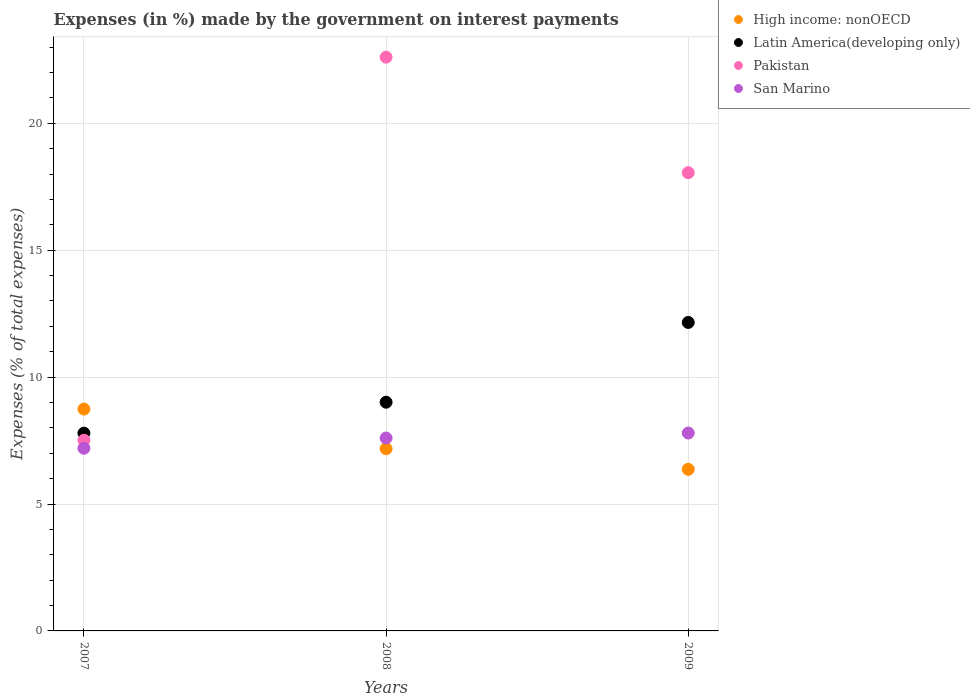How many different coloured dotlines are there?
Your answer should be compact. 4. Is the number of dotlines equal to the number of legend labels?
Ensure brevity in your answer.  Yes. What is the percentage of expenses made by the government on interest payments in Latin America(developing only) in 2009?
Provide a succinct answer. 12.15. Across all years, what is the maximum percentage of expenses made by the government on interest payments in High income: nonOECD?
Provide a short and direct response. 8.74. Across all years, what is the minimum percentage of expenses made by the government on interest payments in Pakistan?
Offer a very short reply. 7.51. What is the total percentage of expenses made by the government on interest payments in Latin America(developing only) in the graph?
Your response must be concise. 28.96. What is the difference between the percentage of expenses made by the government on interest payments in High income: nonOECD in 2007 and that in 2008?
Keep it short and to the point. 1.56. What is the difference between the percentage of expenses made by the government on interest payments in High income: nonOECD in 2008 and the percentage of expenses made by the government on interest payments in San Marino in 2009?
Give a very brief answer. -0.62. What is the average percentage of expenses made by the government on interest payments in High income: nonOECD per year?
Give a very brief answer. 7.43. In the year 2007, what is the difference between the percentage of expenses made by the government on interest payments in High income: nonOECD and percentage of expenses made by the government on interest payments in Latin America(developing only)?
Your answer should be very brief. 0.95. In how many years, is the percentage of expenses made by the government on interest payments in Latin America(developing only) greater than 9 %?
Keep it short and to the point. 2. What is the ratio of the percentage of expenses made by the government on interest payments in San Marino in 2007 to that in 2009?
Your answer should be very brief. 0.92. Is the difference between the percentage of expenses made by the government on interest payments in High income: nonOECD in 2008 and 2009 greater than the difference between the percentage of expenses made by the government on interest payments in Latin America(developing only) in 2008 and 2009?
Your response must be concise. Yes. What is the difference between the highest and the second highest percentage of expenses made by the government on interest payments in San Marino?
Offer a terse response. 0.2. What is the difference between the highest and the lowest percentage of expenses made by the government on interest payments in High income: nonOECD?
Keep it short and to the point. 2.37. In how many years, is the percentage of expenses made by the government on interest payments in High income: nonOECD greater than the average percentage of expenses made by the government on interest payments in High income: nonOECD taken over all years?
Your answer should be very brief. 1. Is the sum of the percentage of expenses made by the government on interest payments in High income: nonOECD in 2007 and 2009 greater than the maximum percentage of expenses made by the government on interest payments in San Marino across all years?
Make the answer very short. Yes. Does the percentage of expenses made by the government on interest payments in Latin America(developing only) monotonically increase over the years?
Ensure brevity in your answer.  Yes. Is the percentage of expenses made by the government on interest payments in San Marino strictly greater than the percentage of expenses made by the government on interest payments in Pakistan over the years?
Provide a succinct answer. No. How many dotlines are there?
Keep it short and to the point. 4. How many legend labels are there?
Keep it short and to the point. 4. What is the title of the graph?
Ensure brevity in your answer.  Expenses (in %) made by the government on interest payments. Does "Aruba" appear as one of the legend labels in the graph?
Your response must be concise. No. What is the label or title of the Y-axis?
Give a very brief answer. Expenses (% of total expenses). What is the Expenses (% of total expenses) in High income: nonOECD in 2007?
Ensure brevity in your answer.  8.74. What is the Expenses (% of total expenses) of Latin America(developing only) in 2007?
Your response must be concise. 7.79. What is the Expenses (% of total expenses) in Pakistan in 2007?
Your answer should be compact. 7.51. What is the Expenses (% of total expenses) of San Marino in 2007?
Offer a very short reply. 7.2. What is the Expenses (% of total expenses) in High income: nonOECD in 2008?
Provide a succinct answer. 7.18. What is the Expenses (% of total expenses) in Latin America(developing only) in 2008?
Give a very brief answer. 9.01. What is the Expenses (% of total expenses) in Pakistan in 2008?
Your response must be concise. 22.6. What is the Expenses (% of total expenses) of San Marino in 2008?
Give a very brief answer. 7.6. What is the Expenses (% of total expenses) in High income: nonOECD in 2009?
Your answer should be very brief. 6.37. What is the Expenses (% of total expenses) of Latin America(developing only) in 2009?
Provide a short and direct response. 12.15. What is the Expenses (% of total expenses) in Pakistan in 2009?
Offer a terse response. 18.05. What is the Expenses (% of total expenses) of San Marino in 2009?
Your answer should be very brief. 7.8. Across all years, what is the maximum Expenses (% of total expenses) in High income: nonOECD?
Provide a succinct answer. 8.74. Across all years, what is the maximum Expenses (% of total expenses) in Latin America(developing only)?
Your answer should be compact. 12.15. Across all years, what is the maximum Expenses (% of total expenses) of Pakistan?
Your answer should be very brief. 22.6. Across all years, what is the maximum Expenses (% of total expenses) in San Marino?
Ensure brevity in your answer.  7.8. Across all years, what is the minimum Expenses (% of total expenses) of High income: nonOECD?
Your answer should be very brief. 6.37. Across all years, what is the minimum Expenses (% of total expenses) of Latin America(developing only)?
Provide a short and direct response. 7.79. Across all years, what is the minimum Expenses (% of total expenses) in Pakistan?
Offer a terse response. 7.51. Across all years, what is the minimum Expenses (% of total expenses) in San Marino?
Ensure brevity in your answer.  7.2. What is the total Expenses (% of total expenses) of High income: nonOECD in the graph?
Offer a terse response. 22.29. What is the total Expenses (% of total expenses) in Latin America(developing only) in the graph?
Your response must be concise. 28.96. What is the total Expenses (% of total expenses) of Pakistan in the graph?
Provide a succinct answer. 48.17. What is the total Expenses (% of total expenses) of San Marino in the graph?
Your answer should be very brief. 22.59. What is the difference between the Expenses (% of total expenses) of High income: nonOECD in 2007 and that in 2008?
Offer a very short reply. 1.56. What is the difference between the Expenses (% of total expenses) of Latin America(developing only) in 2007 and that in 2008?
Give a very brief answer. -1.22. What is the difference between the Expenses (% of total expenses) of Pakistan in 2007 and that in 2008?
Your answer should be very brief. -15.09. What is the difference between the Expenses (% of total expenses) in San Marino in 2007 and that in 2008?
Your answer should be very brief. -0.4. What is the difference between the Expenses (% of total expenses) of High income: nonOECD in 2007 and that in 2009?
Provide a short and direct response. 2.37. What is the difference between the Expenses (% of total expenses) in Latin America(developing only) in 2007 and that in 2009?
Your response must be concise. -4.36. What is the difference between the Expenses (% of total expenses) in Pakistan in 2007 and that in 2009?
Your response must be concise. -10.54. What is the difference between the Expenses (% of total expenses) of San Marino in 2007 and that in 2009?
Provide a succinct answer. -0.6. What is the difference between the Expenses (% of total expenses) of High income: nonOECD in 2008 and that in 2009?
Keep it short and to the point. 0.81. What is the difference between the Expenses (% of total expenses) in Latin America(developing only) in 2008 and that in 2009?
Provide a short and direct response. -3.14. What is the difference between the Expenses (% of total expenses) in Pakistan in 2008 and that in 2009?
Provide a succinct answer. 4.55. What is the difference between the Expenses (% of total expenses) of San Marino in 2008 and that in 2009?
Give a very brief answer. -0.2. What is the difference between the Expenses (% of total expenses) of High income: nonOECD in 2007 and the Expenses (% of total expenses) of Latin America(developing only) in 2008?
Offer a terse response. -0.27. What is the difference between the Expenses (% of total expenses) in High income: nonOECD in 2007 and the Expenses (% of total expenses) in Pakistan in 2008?
Your answer should be very brief. -13.86. What is the difference between the Expenses (% of total expenses) of High income: nonOECD in 2007 and the Expenses (% of total expenses) of San Marino in 2008?
Keep it short and to the point. 1.14. What is the difference between the Expenses (% of total expenses) of Latin America(developing only) in 2007 and the Expenses (% of total expenses) of Pakistan in 2008?
Offer a terse response. -14.81. What is the difference between the Expenses (% of total expenses) in Latin America(developing only) in 2007 and the Expenses (% of total expenses) in San Marino in 2008?
Your response must be concise. 0.19. What is the difference between the Expenses (% of total expenses) of Pakistan in 2007 and the Expenses (% of total expenses) of San Marino in 2008?
Give a very brief answer. -0.09. What is the difference between the Expenses (% of total expenses) in High income: nonOECD in 2007 and the Expenses (% of total expenses) in Latin America(developing only) in 2009?
Make the answer very short. -3.41. What is the difference between the Expenses (% of total expenses) in High income: nonOECD in 2007 and the Expenses (% of total expenses) in Pakistan in 2009?
Offer a very short reply. -9.31. What is the difference between the Expenses (% of total expenses) in High income: nonOECD in 2007 and the Expenses (% of total expenses) in San Marino in 2009?
Ensure brevity in your answer.  0.94. What is the difference between the Expenses (% of total expenses) of Latin America(developing only) in 2007 and the Expenses (% of total expenses) of Pakistan in 2009?
Your response must be concise. -10.26. What is the difference between the Expenses (% of total expenses) of Latin America(developing only) in 2007 and the Expenses (% of total expenses) of San Marino in 2009?
Your answer should be very brief. -0. What is the difference between the Expenses (% of total expenses) in Pakistan in 2007 and the Expenses (% of total expenses) in San Marino in 2009?
Provide a succinct answer. -0.28. What is the difference between the Expenses (% of total expenses) in High income: nonOECD in 2008 and the Expenses (% of total expenses) in Latin America(developing only) in 2009?
Your response must be concise. -4.98. What is the difference between the Expenses (% of total expenses) in High income: nonOECD in 2008 and the Expenses (% of total expenses) in Pakistan in 2009?
Offer a terse response. -10.87. What is the difference between the Expenses (% of total expenses) in High income: nonOECD in 2008 and the Expenses (% of total expenses) in San Marino in 2009?
Ensure brevity in your answer.  -0.62. What is the difference between the Expenses (% of total expenses) in Latin America(developing only) in 2008 and the Expenses (% of total expenses) in Pakistan in 2009?
Ensure brevity in your answer.  -9.04. What is the difference between the Expenses (% of total expenses) of Latin America(developing only) in 2008 and the Expenses (% of total expenses) of San Marino in 2009?
Offer a very short reply. 1.21. What is the difference between the Expenses (% of total expenses) in Pakistan in 2008 and the Expenses (% of total expenses) in San Marino in 2009?
Your answer should be very brief. 14.81. What is the average Expenses (% of total expenses) in High income: nonOECD per year?
Offer a terse response. 7.43. What is the average Expenses (% of total expenses) of Latin America(developing only) per year?
Ensure brevity in your answer.  9.65. What is the average Expenses (% of total expenses) of Pakistan per year?
Provide a short and direct response. 16.06. What is the average Expenses (% of total expenses) of San Marino per year?
Provide a short and direct response. 7.53. In the year 2007, what is the difference between the Expenses (% of total expenses) in High income: nonOECD and Expenses (% of total expenses) in Latin America(developing only)?
Your answer should be very brief. 0.95. In the year 2007, what is the difference between the Expenses (% of total expenses) of High income: nonOECD and Expenses (% of total expenses) of Pakistan?
Make the answer very short. 1.23. In the year 2007, what is the difference between the Expenses (% of total expenses) in High income: nonOECD and Expenses (% of total expenses) in San Marino?
Keep it short and to the point. 1.54. In the year 2007, what is the difference between the Expenses (% of total expenses) of Latin America(developing only) and Expenses (% of total expenses) of Pakistan?
Make the answer very short. 0.28. In the year 2007, what is the difference between the Expenses (% of total expenses) of Latin America(developing only) and Expenses (% of total expenses) of San Marino?
Your response must be concise. 0.6. In the year 2007, what is the difference between the Expenses (% of total expenses) of Pakistan and Expenses (% of total expenses) of San Marino?
Your answer should be very brief. 0.32. In the year 2008, what is the difference between the Expenses (% of total expenses) in High income: nonOECD and Expenses (% of total expenses) in Latin America(developing only)?
Offer a terse response. -1.83. In the year 2008, what is the difference between the Expenses (% of total expenses) of High income: nonOECD and Expenses (% of total expenses) of Pakistan?
Offer a terse response. -15.43. In the year 2008, what is the difference between the Expenses (% of total expenses) of High income: nonOECD and Expenses (% of total expenses) of San Marino?
Offer a terse response. -0.42. In the year 2008, what is the difference between the Expenses (% of total expenses) in Latin America(developing only) and Expenses (% of total expenses) in Pakistan?
Give a very brief answer. -13.59. In the year 2008, what is the difference between the Expenses (% of total expenses) of Latin America(developing only) and Expenses (% of total expenses) of San Marino?
Keep it short and to the point. 1.41. In the year 2008, what is the difference between the Expenses (% of total expenses) in Pakistan and Expenses (% of total expenses) in San Marino?
Offer a terse response. 15. In the year 2009, what is the difference between the Expenses (% of total expenses) of High income: nonOECD and Expenses (% of total expenses) of Latin America(developing only)?
Provide a succinct answer. -5.79. In the year 2009, what is the difference between the Expenses (% of total expenses) in High income: nonOECD and Expenses (% of total expenses) in Pakistan?
Provide a succinct answer. -11.69. In the year 2009, what is the difference between the Expenses (% of total expenses) of High income: nonOECD and Expenses (% of total expenses) of San Marino?
Keep it short and to the point. -1.43. In the year 2009, what is the difference between the Expenses (% of total expenses) in Latin America(developing only) and Expenses (% of total expenses) in Pakistan?
Provide a short and direct response. -5.9. In the year 2009, what is the difference between the Expenses (% of total expenses) of Latin America(developing only) and Expenses (% of total expenses) of San Marino?
Offer a very short reply. 4.36. In the year 2009, what is the difference between the Expenses (% of total expenses) in Pakistan and Expenses (% of total expenses) in San Marino?
Make the answer very short. 10.26. What is the ratio of the Expenses (% of total expenses) in High income: nonOECD in 2007 to that in 2008?
Provide a short and direct response. 1.22. What is the ratio of the Expenses (% of total expenses) in Latin America(developing only) in 2007 to that in 2008?
Give a very brief answer. 0.86. What is the ratio of the Expenses (% of total expenses) in Pakistan in 2007 to that in 2008?
Offer a terse response. 0.33. What is the ratio of the Expenses (% of total expenses) in San Marino in 2007 to that in 2008?
Your answer should be very brief. 0.95. What is the ratio of the Expenses (% of total expenses) of High income: nonOECD in 2007 to that in 2009?
Your answer should be very brief. 1.37. What is the ratio of the Expenses (% of total expenses) of Latin America(developing only) in 2007 to that in 2009?
Your response must be concise. 0.64. What is the ratio of the Expenses (% of total expenses) of Pakistan in 2007 to that in 2009?
Provide a succinct answer. 0.42. What is the ratio of the Expenses (% of total expenses) of San Marino in 2007 to that in 2009?
Give a very brief answer. 0.92. What is the ratio of the Expenses (% of total expenses) in High income: nonOECD in 2008 to that in 2009?
Provide a short and direct response. 1.13. What is the ratio of the Expenses (% of total expenses) in Latin America(developing only) in 2008 to that in 2009?
Your answer should be very brief. 0.74. What is the ratio of the Expenses (% of total expenses) of Pakistan in 2008 to that in 2009?
Your answer should be very brief. 1.25. What is the ratio of the Expenses (% of total expenses) in San Marino in 2008 to that in 2009?
Provide a short and direct response. 0.97. What is the difference between the highest and the second highest Expenses (% of total expenses) of High income: nonOECD?
Keep it short and to the point. 1.56. What is the difference between the highest and the second highest Expenses (% of total expenses) in Latin America(developing only)?
Your response must be concise. 3.14. What is the difference between the highest and the second highest Expenses (% of total expenses) in Pakistan?
Provide a succinct answer. 4.55. What is the difference between the highest and the second highest Expenses (% of total expenses) in San Marino?
Ensure brevity in your answer.  0.2. What is the difference between the highest and the lowest Expenses (% of total expenses) of High income: nonOECD?
Your response must be concise. 2.37. What is the difference between the highest and the lowest Expenses (% of total expenses) in Latin America(developing only)?
Give a very brief answer. 4.36. What is the difference between the highest and the lowest Expenses (% of total expenses) of Pakistan?
Give a very brief answer. 15.09. What is the difference between the highest and the lowest Expenses (% of total expenses) of San Marino?
Provide a succinct answer. 0.6. 